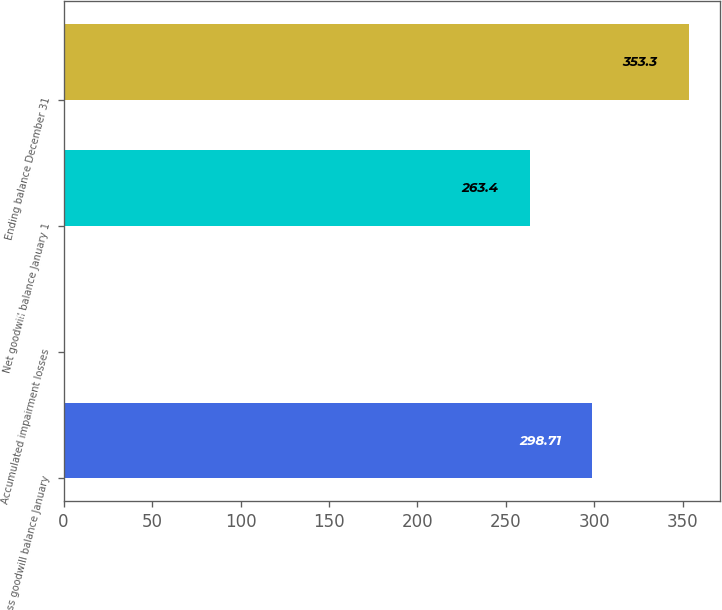<chart> <loc_0><loc_0><loc_500><loc_500><bar_chart><fcel>Gross goodwill balance January<fcel>Accumulated impairment losses<fcel>Net goodwill balance January 1<fcel>Ending balance December 31<nl><fcel>298.71<fcel>0.2<fcel>263.4<fcel>353.3<nl></chart> 